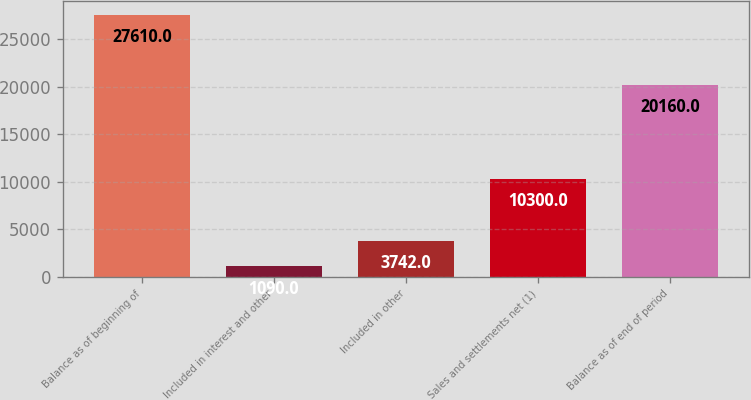Convert chart to OTSL. <chart><loc_0><loc_0><loc_500><loc_500><bar_chart><fcel>Balance as of beginning of<fcel>Included in interest and other<fcel>Included in other<fcel>Sales and settlements net (1)<fcel>Balance as of end of period<nl><fcel>27610<fcel>1090<fcel>3742<fcel>10300<fcel>20160<nl></chart> 